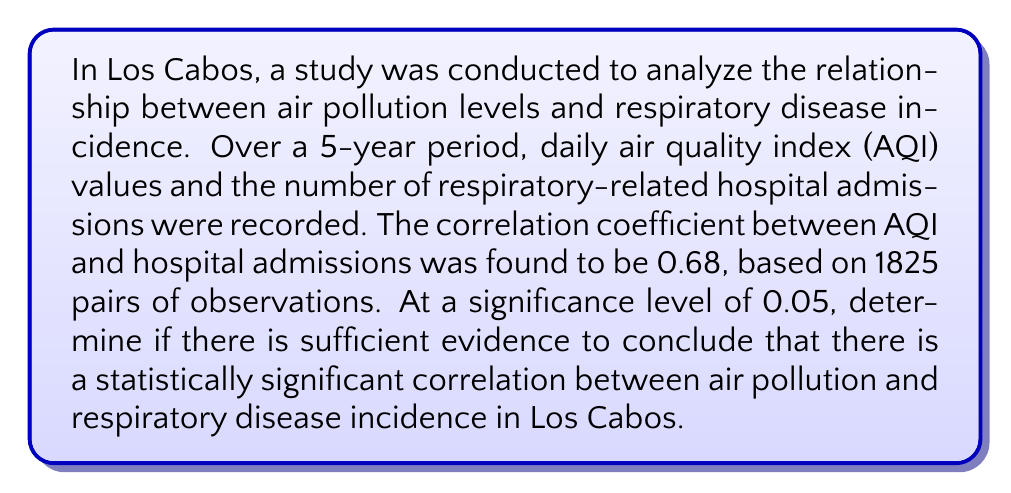Teach me how to tackle this problem. To determine if there is a statistically significant correlation, we'll use the following steps:

1. State the null and alternative hypotheses:
   $H_0: \rho = 0$ (no correlation)
   $H_a: \rho \neq 0$ (correlation exists)

2. Calculate the test statistic:
   For large samples (n > 30), we can use the t-test:
   $$t = r \sqrt{\frac{n-2}{1-r^2}}$$
   where r is the sample correlation coefficient and n is the sample size.

   $$t = 0.68 \sqrt{\frac{1825-2}{1-0.68^2}} = 39.73$$

3. Determine the critical value:
   For a two-tailed test with α = 0.05 and df = 1823, the critical value is approximately ±1.96 (using the normal distribution as an approximation for large df).

4. Compare the test statistic to the critical value:
   |39.73| > 1.96, so we reject the null hypothesis.

5. Calculate the p-value:
   The p-value is extremely small (p < 0.0001), much less than the significance level of 0.05.

Given that the test statistic (39.73) is much larger than the critical value (1.96) and the p-value is much smaller than the significance level (0.05), we have strong evidence to reject the null hypothesis.
Answer: Statistically significant correlation exists (p < 0.0001) 